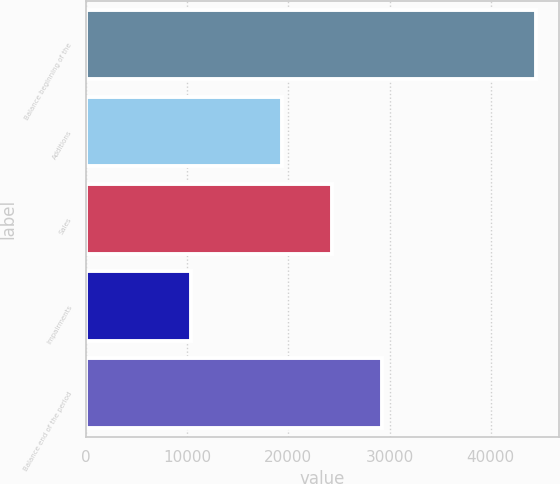<chart> <loc_0><loc_0><loc_500><loc_500><bar_chart><fcel>Balance beginning of the<fcel>Additions<fcel>Sales<fcel>Impairments<fcel>Balance end of the period<nl><fcel>44533<fcel>19341<fcel>24308<fcel>10314<fcel>29252<nl></chart> 